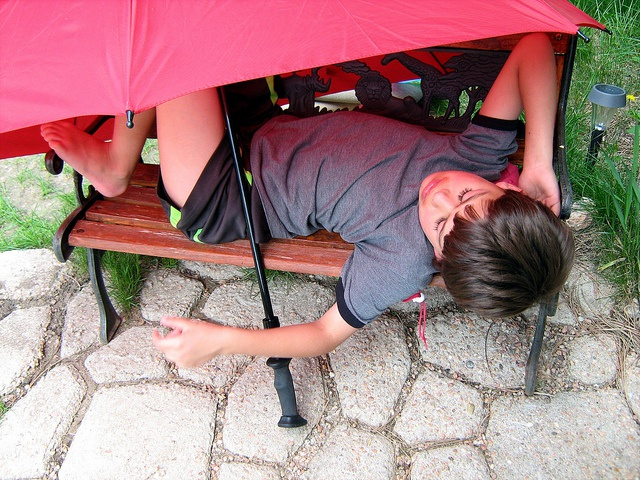Describe the objects in this image and their specific colors. I can see people in salmon, black, lightpink, gray, and maroon tones, umbrella in salmon, brown, and black tones, and bench in salmon, brown, black, and maroon tones in this image. 